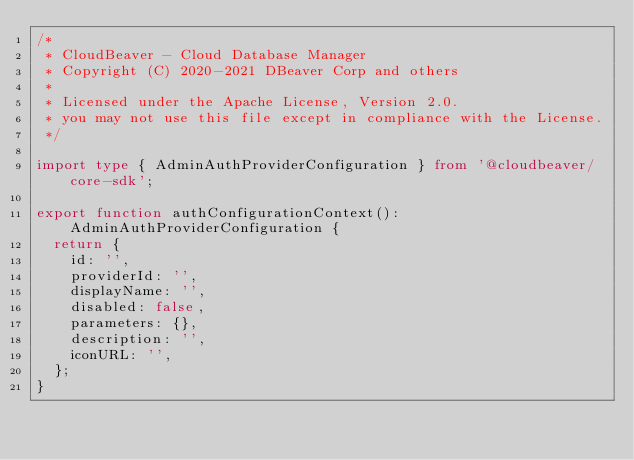Convert code to text. <code><loc_0><loc_0><loc_500><loc_500><_TypeScript_>/*
 * CloudBeaver - Cloud Database Manager
 * Copyright (C) 2020-2021 DBeaver Corp and others
 *
 * Licensed under the Apache License, Version 2.0.
 * you may not use this file except in compliance with the License.
 */

import type { AdminAuthProviderConfiguration } from '@cloudbeaver/core-sdk';

export function authConfigurationContext(): AdminAuthProviderConfiguration {
  return {
    id: '',
    providerId: '',
    displayName: '',
    disabled: false,
    parameters: {},
    description: '',
    iconURL: '',
  };
}
</code> 